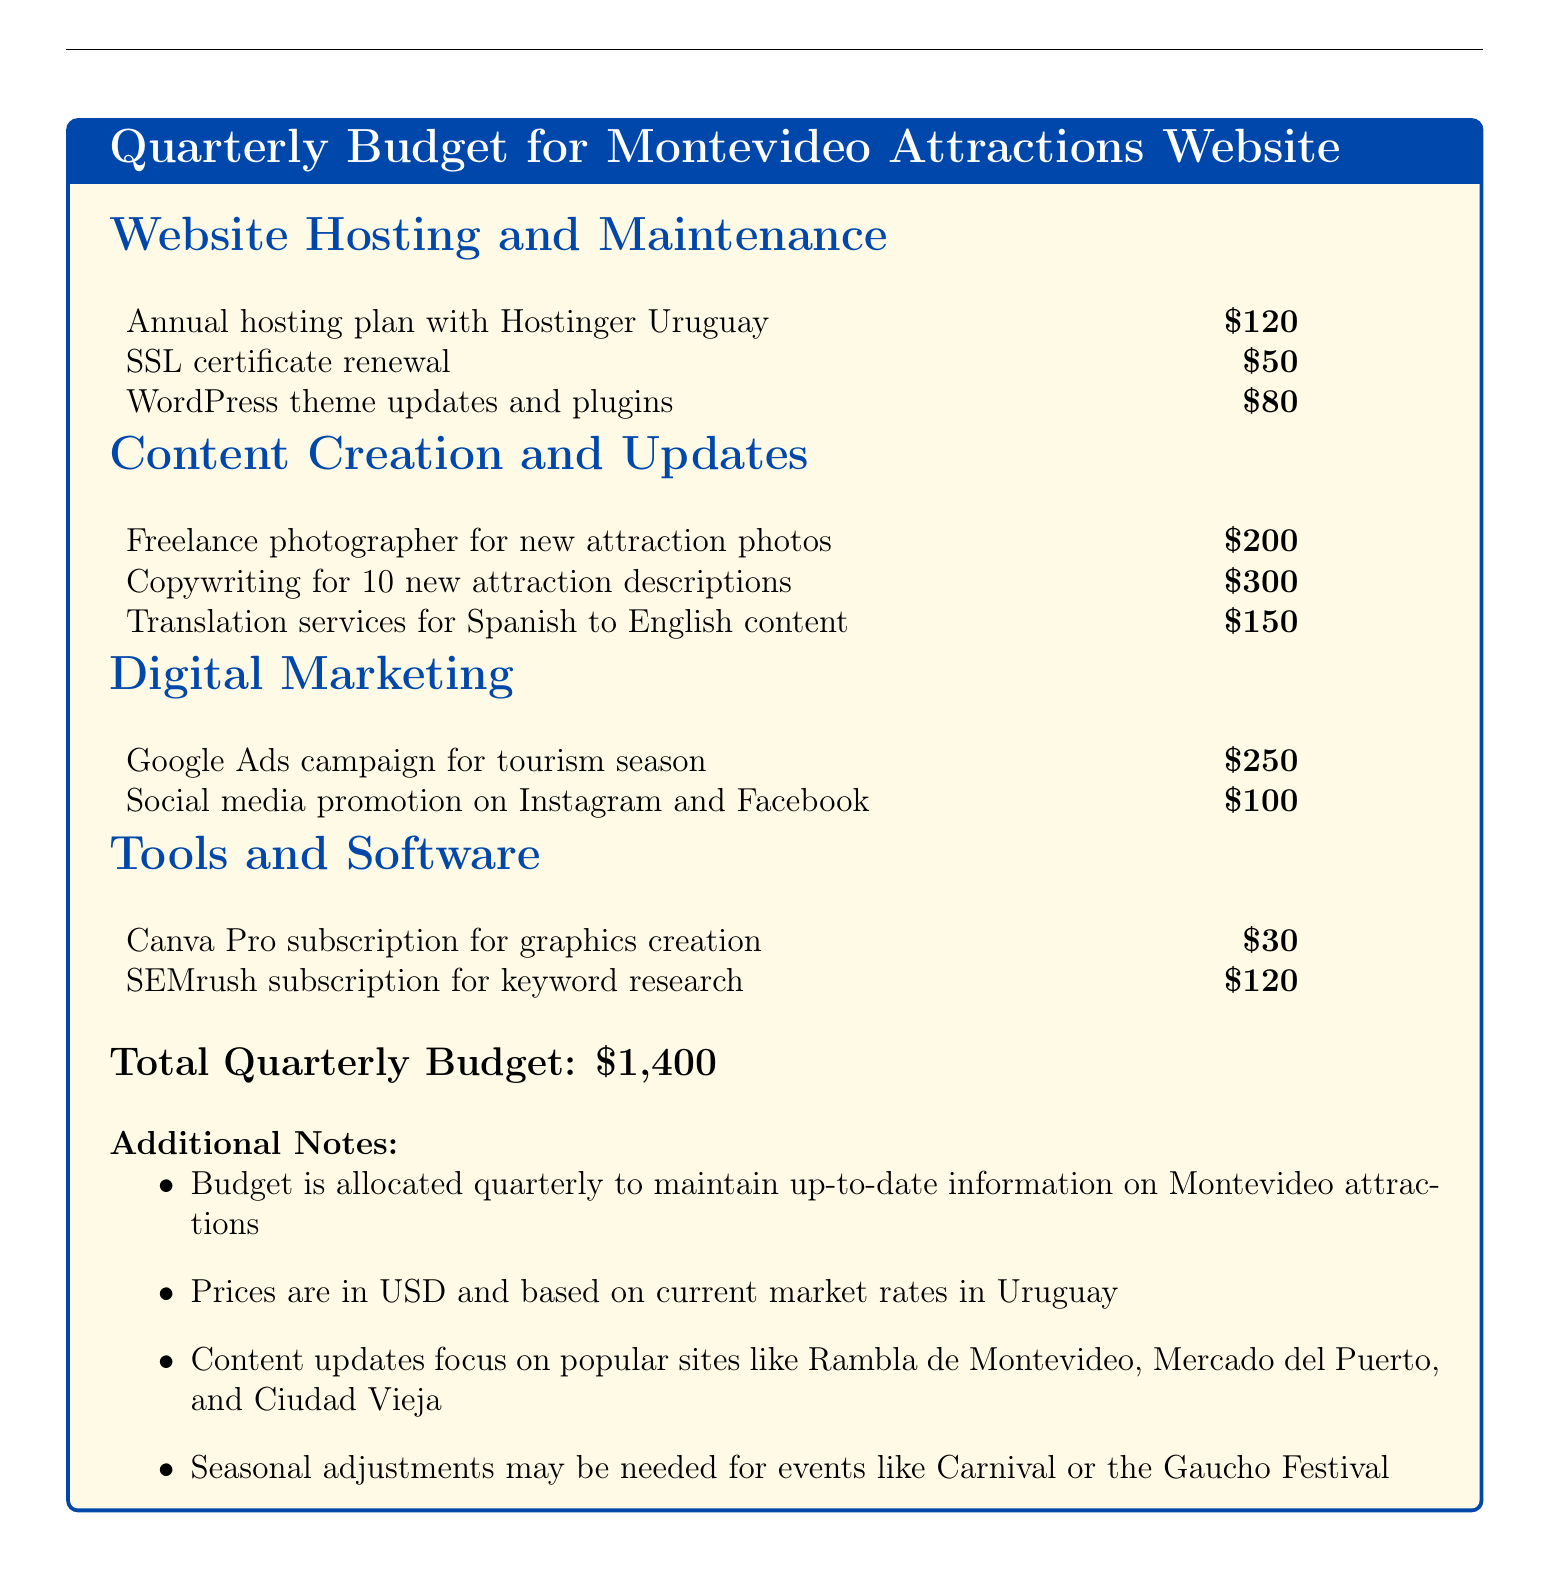What is the total quarterly budget? The total quarterly budget is explicitly stated at the end of the document.
Answer: $1,400 How much is allocated for freelance photography? The cost for hiring a freelance photographer for new attraction photos is listed in the Content Creation section.
Answer: $200 What is the renewal cost of the SSL certificate? The renewal cost of the SSL certificate is provided in the Website Hosting and Maintenance section.
Answer: $50 What is the cost of the Canva Pro subscription? The cost for Canva Pro subscription is noted in the Tools and Software section.
Answer: $30 What type of marketing campaign is planned during the tourism season? The document specifies the type of marketing campaign under the Digital Marketing section.
Answer: Google Ads campaign How many new attraction descriptions will be written? The number of new attraction descriptions is mentioned in the Content Creation section.
Answer: 10 How much is budgeted for social media promotion? The budget for social media promotion is indicated in the Digital Marketing section.
Answer: $100 What software is used for keyword research? The document lists the tool used for keyword research in the Tools and Software section.
Answer: SEMrush How often is the budget allocated? The frequency of the budget allocation is detailed in the Additional Notes section.
Answer: Quarterly 